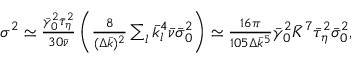<formula> <loc_0><loc_0><loc_500><loc_500>\begin{array} { r } { \sigma ^ { 2 } \simeq \frac { \bar { \gamma } _ { 0 } ^ { 2 } \bar { \tau } _ { \eta } ^ { 2 } } { 3 0 \bar { \nu } } \left ( \frac { 8 } { ( \Delta \bar { k } ) ^ { 2 } } \sum _ { l } \bar { k } _ { l } ^ { 4 } \bar { \nu } \bar { \sigma } _ { 0 } ^ { 2 } \right ) \simeq \frac { 1 6 \pi } { 1 0 5 \Delta \bar { k } ^ { 5 } } \bar { \gamma } _ { 0 } ^ { 2 } \bar { K } ^ { 7 } \bar { \tau } _ { \eta } ^ { 2 } \bar { \sigma } _ { 0 } ^ { 2 } , } \end{array}</formula> 